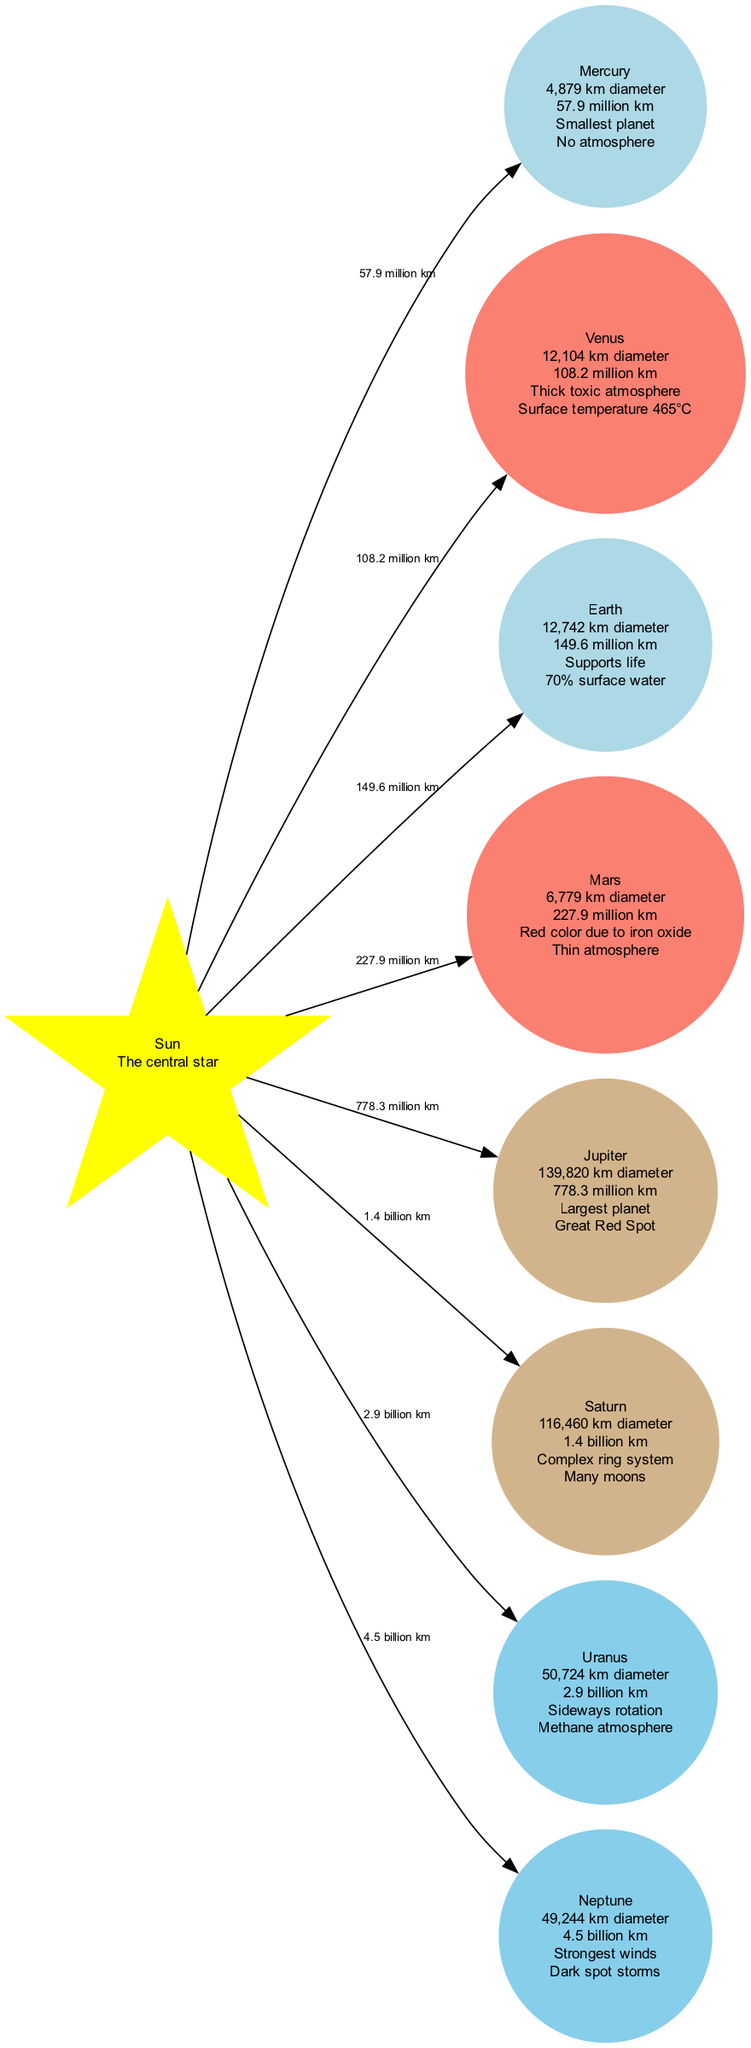What is the size of Jupiter? To find Jupiter's size, I locate the node labeled "Jupiter" in the diagram. The information indicates that Jupiter has a diameter of "139,820 km."
Answer: 139,820 km diameter How far is Mars from the Sun? I look for the Mars node in the diagram and read the distance listed under it. Mars is "227.9 million km" from the Sun according to the diagram.
Answer: 227.9 million km What are the key features of Neptune? I identify the Neptune node, then check for the key features listed below its size and distance information. The key features state: "Strongest winds, Dark spot storms."
Answer: Strongest winds, Dark spot storms Which planet has the thickest atmosphere? I analyze the key features of Venus from its node. The diagram mentions that Venus has a "Thick toxic atmosphere," which indicates it has the thickest atmosphere among the listed planets.
Answer: Venus Which planet is the smallest? I assess the sizes of all the planets. According to the diagram, Mercury is mentioned as the "Smallest planet," making it clear that Mercury is the answer.
Answer: Mercury Which two planets have a methane atmosphere? I examine the nodes for both Uranus and Neptune, focusing on the key features under each. The node for Uranus specifies it has a "Methane atmosphere," while Neptune's features do not mention methane. Thus, Uranus is the answer.
Answer: Uranus How many planets are closer to the Sun than Earth? I evaluate the distances of Mercury, Venus, and Mars from the Sun. Both Mercury and Venus are closer than Earth, which is "149.6 million km" away. Therefore, there are two planets closer to the Sun than Earth.
Answer: 2 What is the size comparison between Saturn and Uranus? I compare the sizes of both planets by checking their respective size descriptions. Saturn's diameter is "116,460 km" while Uranus has a diameter of "50,724 km." It's clear that Saturn is larger.
Answer: Saturn is larger What planet has the greatest distance from the Sun? I review the distance values listed for each planet. Neptune has the highest distance marked at "4.5 billion km," making it the planet that is farthest from the Sun.
Answer: Neptune 